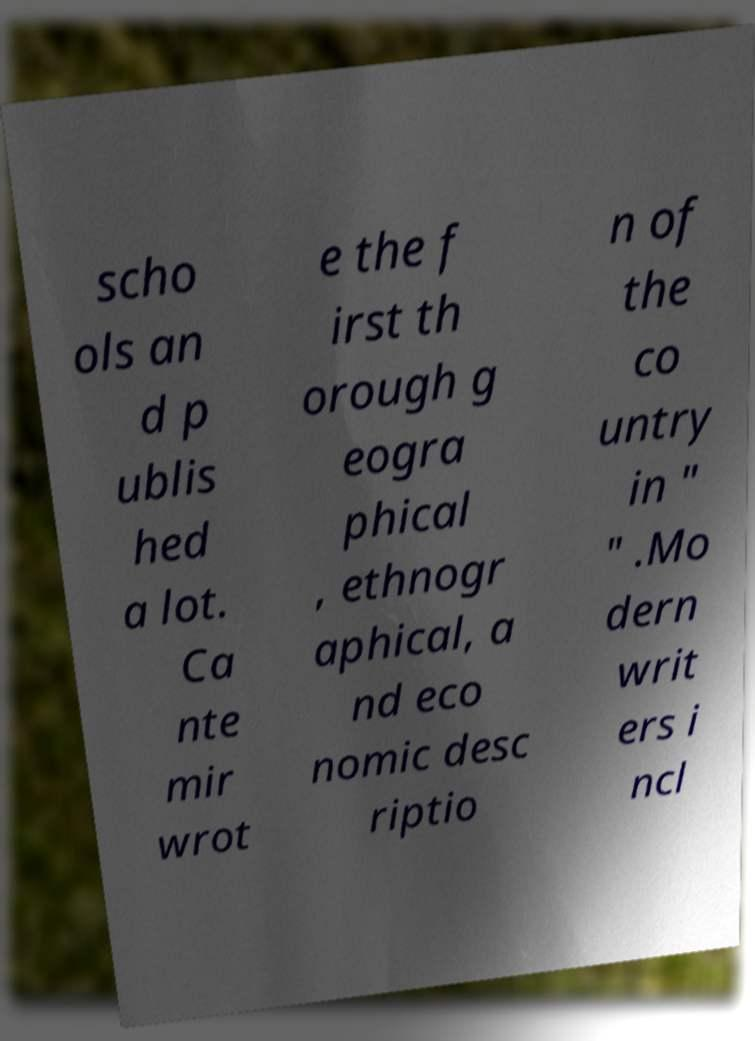For documentation purposes, I need the text within this image transcribed. Could you provide that? scho ols an d p ublis hed a lot. Ca nte mir wrot e the f irst th orough g eogra phical , ethnogr aphical, a nd eco nomic desc riptio n of the co untry in " " .Mo dern writ ers i ncl 